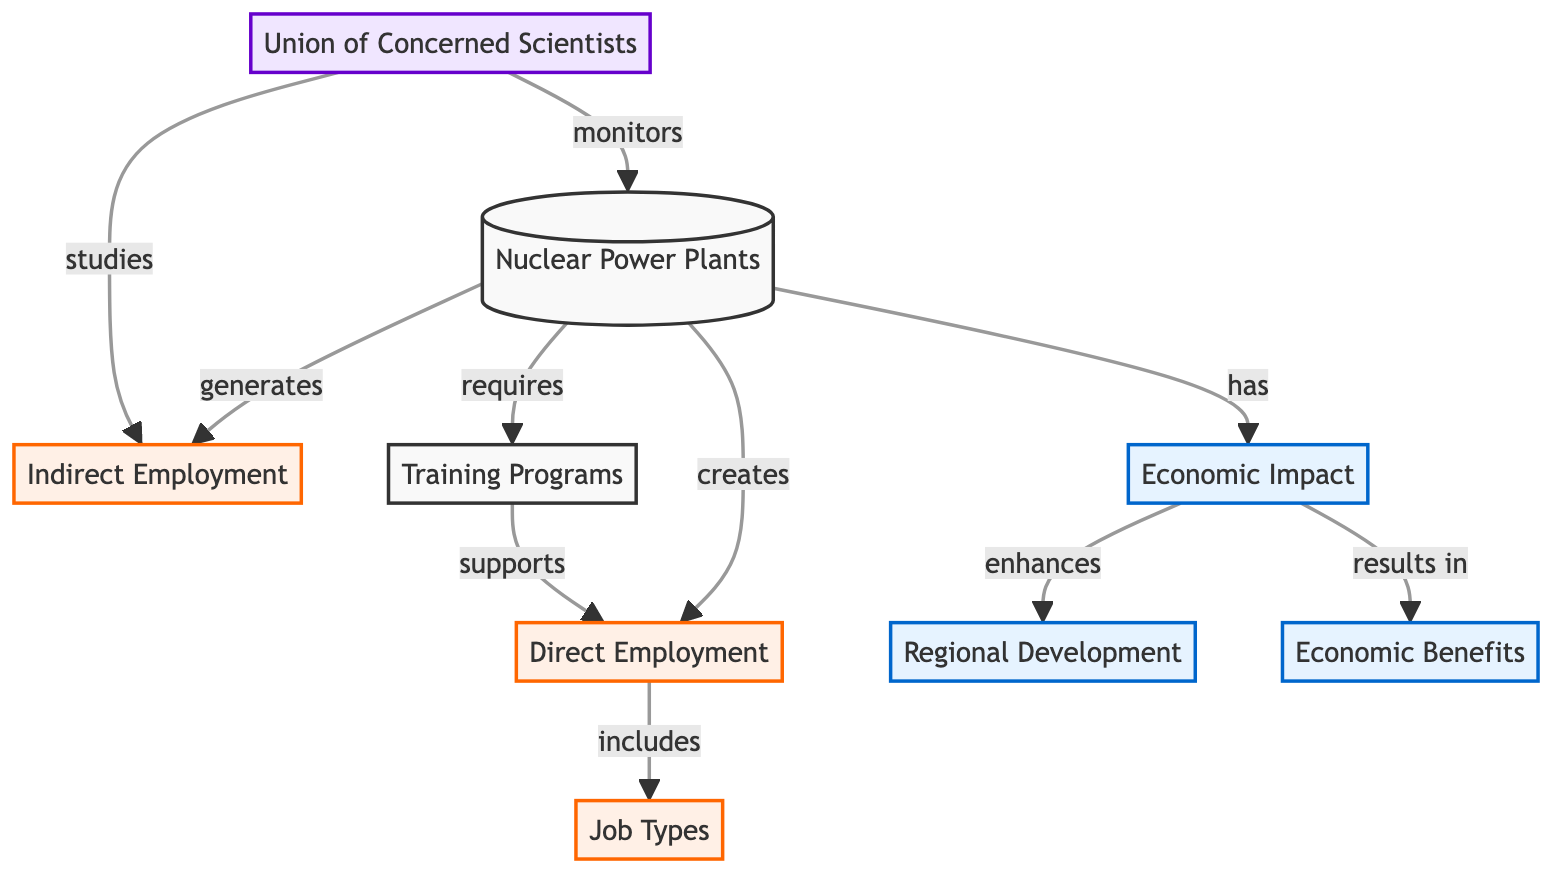What creates direct employment in the nuclear sector? The diagram shows that Nuclear Power Plants create Direct Employment. This is indicated by the arrow directing from "Nuclear Power Plants" to "Direct Employment."
Answer: Nuclear Power Plants What does indirect employment in the nuclear sector generate? According to the diagram, Indirect Employment is generated by Nuclear Power Plants, as illustrated by the connection from "Nuclear Power Plants" to "Indirect Employment."
Answer: Nuclear Power Plants How many job types are included under direct employment? The diagram shows one node labeled "Job Types" connected to "Direct Employment." Thus, it indicates that there is one specific concept regarding job types, but it doesn't break down into further specific types.
Answer: Job Types What enhances regional development in the nuclear sector? The diagram indicates that Economic Impact enhances Regional Development. This is shown by the arrow from "Economic Impact" going to "Regional Development."
Answer: Economic Impact What supports direct employment in the nuclear sector? The diagram states that Training Programs support Direct Employment, displayed by the link from "Training Programs" to "Direct Employment."
Answer: Training Programs What organization monitors nuclear power plants? The diagram specifies that the Union of Concerned Scientists monitors Nuclear Power Plants, which is evident from the link directing from "Union of Concerned Scientists" to "Nuclear Power Plants."
Answer: Union of Concerned Scientists What is the relationship between economic impact and economic benefits? The diagram shows that Economic Impact results in Economic Benefits, as seen where "Economic Impact" leads toward "Economic Benefits."
Answer: Economic Impact Which type of employment is directly linked to job types? The diagram clearly illustrates that Direct Employment includes Job Types, shown by the connection from "Direct Employment" to "Job Types."
Answer: Direct Employment What generates economic benefits in the nuclear sector? The diagram indicates that Economic Impact results in Economic Benefits, which demonstrates the cause-and-effect relationship expressed with the arrow connecting these nodes.
Answer: Economic Impact 